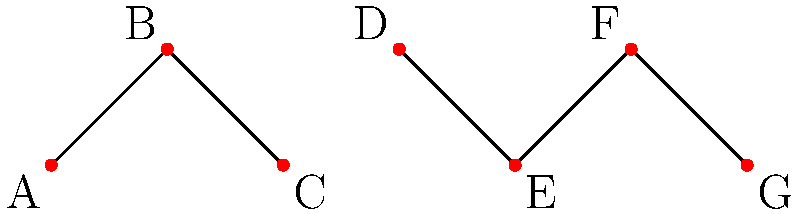In the context of retirement planning, network diagrams can be used to represent connections between various financial instruments. Given the network diagram above, how many connected components are there? (A connected component is a group of vertices that are all reachable from each other.) To determine the number of connected components in this network diagram, we need to identify groups of vertices that are connected to each other but not to other groups. Let's analyze the diagram step by step:

1. Start with vertex A:
   - A is connected to B
   - B is connected to C
   - This forms our first connected component: {A, B, C}

2. Move to the next unexamined vertex, D:
   - D is connected to E
   - E is connected to F
   - F is connected to G
   - This forms our second connected component: {D, E, F, G}

3. We have now examined all vertices in the diagram.

4. Count the number of connected components:
   - Component 1: {A, B, C}
   - Component 2: {D, E, F, G}

Therefore, there are 2 connected components in this network diagram.

In the context of retirement planning, this could represent two separate groups of financial instruments or strategies that are interconnected within themselves but not with each other. For example, one group might represent traditional retirement accounts, while the other represents alternative investments.
Answer: 2 